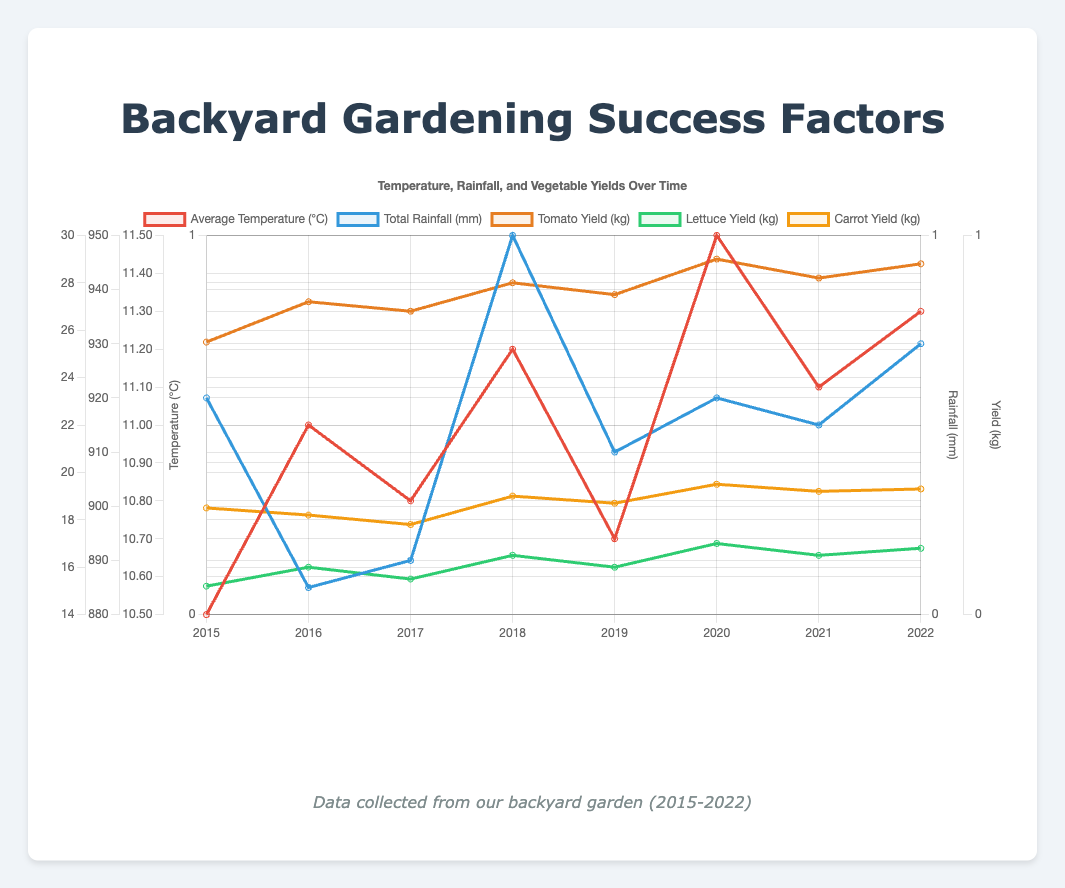How has the average temperature varied over the years? The average temperature has fluctuated slightly over the years, increasing from 10.5°C in 2015 to 11.3°C in 2022, with some ups and downs in the intermediate years.
Answer: It has increased overall with minor fluctuations Which year had the highest total rainfall? By observing the rainfall trend, the highest total rainfall can be identified in 2018 with 950 mm.
Answer: 2018 How did the tomato yield change from 2015 to 2022? The tomato yield has steadily increased from 25.5 kg in 2015 to 28.8 kg in 2022, with minor variations each year.
Answer: It increased overall Is there a correlation between average temperature and tomato yield? Both metrics have shown a generally increasing trend. Tomato yield has increased as the average temperature has also gradually risen from 2015 to 2022.
Answer: Yes, a positive correlation Was the carrot yield higher in 2018 or 2020? The carrot yield in 2018 was 19.0 kg, while in 2020 it was 19.5 kg.
Answer: 2020 How does the lettuce yield in 2016 compare to that in 2022? In 2016, the lettuce yield was 16.0 kg. In 2022, it was 16.8 kg, showing a slight increase over the years.
Answer: 2022 was higher Was there any year where the total rainfall was less than 900 mm? In 2016, the total rainfall was 885 mm, which is less than 900 mm.
Answer: 2016 Compare the average temperature and total rainfall in 2020. The average temperature in 2020 was 11.5°C and the total rainfall was 920 mm.
Answer: 11.5°C and 920 mm 